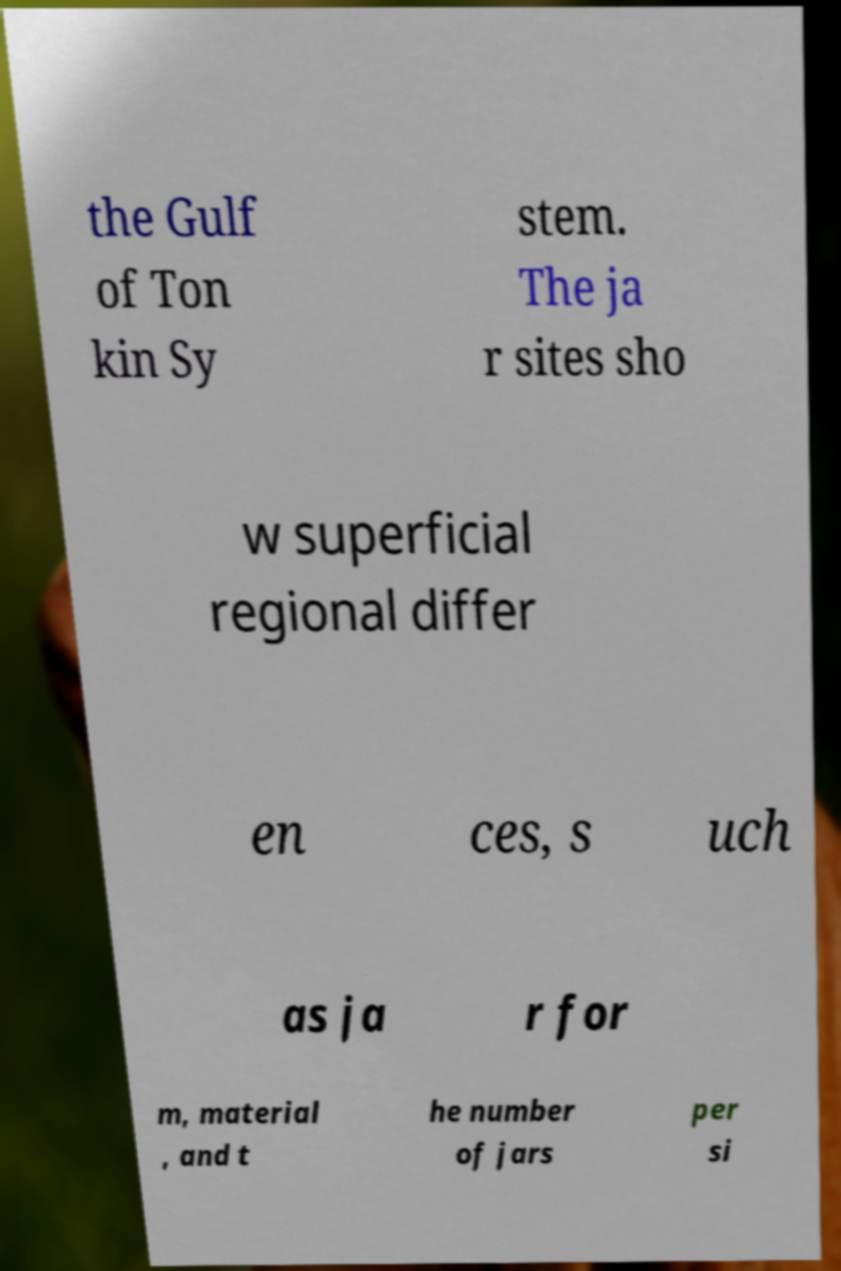For documentation purposes, I need the text within this image transcribed. Could you provide that? the Gulf of Ton kin Sy stem. The ja r sites sho w superficial regional differ en ces, s uch as ja r for m, material , and t he number of jars per si 